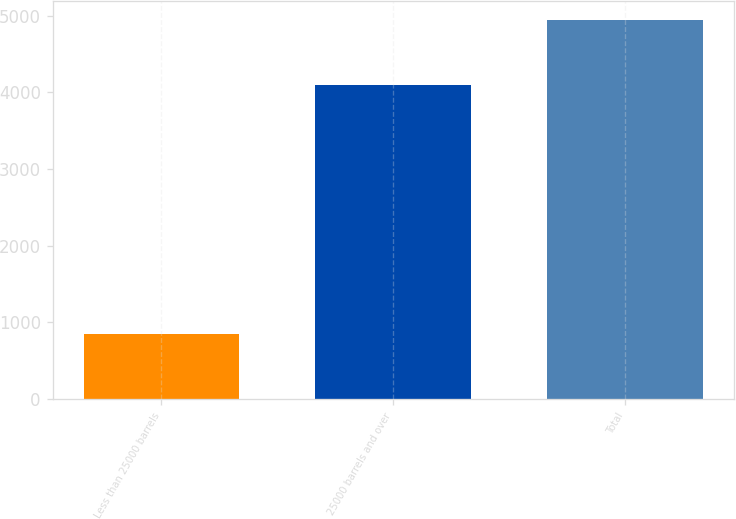Convert chart to OTSL. <chart><loc_0><loc_0><loc_500><loc_500><bar_chart><fcel>Less than 25000 barrels<fcel>25000 barrels and over<fcel>Total<nl><fcel>848<fcel>4097<fcel>4945<nl></chart> 